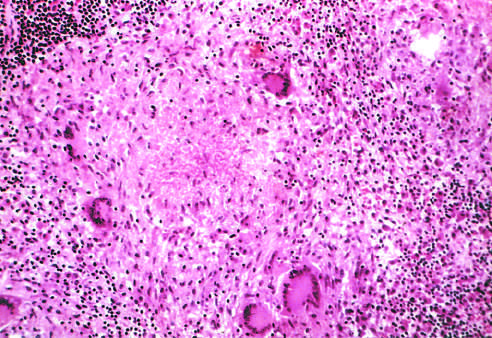dose typical tuberculous granuloma show an area of central necrosis surrounded by multiple multinucleate giant cells, epithelioid cells, and lymphocytes?
Answer the question using a single word or phrase. Yes 